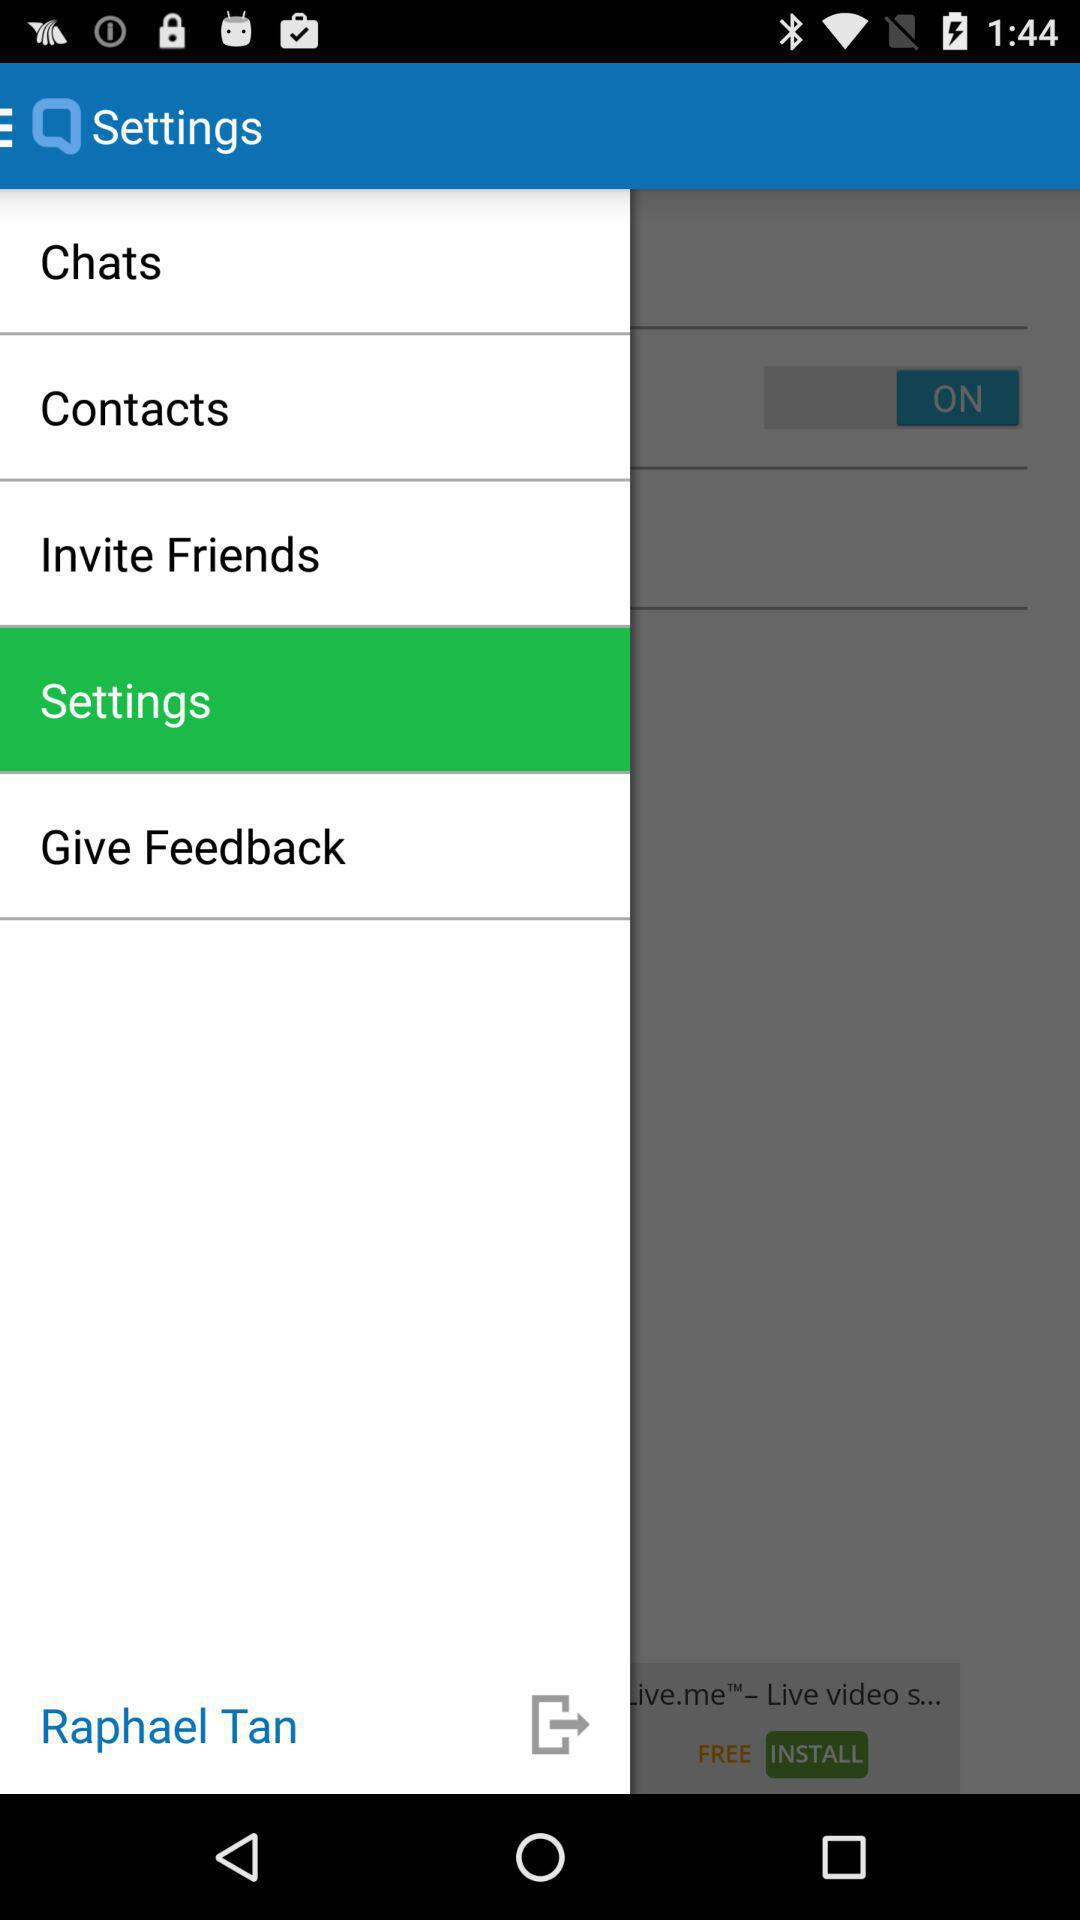What is the user name? The user name is Raphael Tan. 